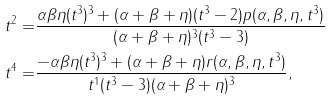<formula> <loc_0><loc_0><loc_500><loc_500>t ^ { 2 } = & \frac { \alpha \beta \eta ( t ^ { 3 } ) ^ { 3 } + ( \alpha + \beta + \eta ) ( t ^ { 3 } - 2 ) p ( \alpha , \beta , \eta , t ^ { 3 } ) } { ( \alpha + \beta + \eta ) ^ { 3 } ( t ^ { 3 } - 3 ) } \\ t ^ { 4 } = & \frac { - \alpha \beta \eta ( t ^ { 3 } ) ^ { 3 } + ( \alpha + \beta + \eta ) r ( \alpha , \beta , \eta , t ^ { 3 } ) } { t ^ { 1 } ( t ^ { 3 } - 3 ) ( \alpha + \beta + \eta ) ^ { 3 } } ,</formula> 